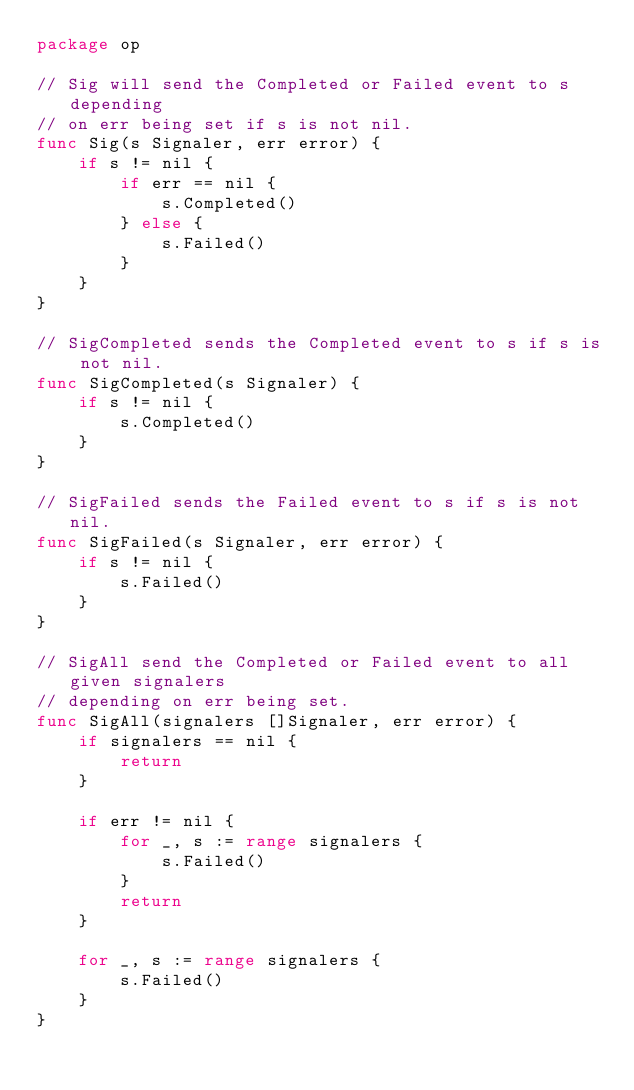Convert code to text. <code><loc_0><loc_0><loc_500><loc_500><_Go_>package op

// Sig will send the Completed or Failed event to s depending
// on err being set if s is not nil.
func Sig(s Signaler, err error) {
	if s != nil {
		if err == nil {
			s.Completed()
		} else {
			s.Failed()
		}
	}
}

// SigCompleted sends the Completed event to s if s is not nil.
func SigCompleted(s Signaler) {
	if s != nil {
		s.Completed()
	}
}

// SigFailed sends the Failed event to s if s is not nil.
func SigFailed(s Signaler, err error) {
	if s != nil {
		s.Failed()
	}
}

// SigAll send the Completed or Failed event to all given signalers
// depending on err being set.
func SigAll(signalers []Signaler, err error) {
	if signalers == nil {
		return
	}

	if err != nil {
		for _, s := range signalers {
			s.Failed()
		}
		return
	}

	for _, s := range signalers {
		s.Failed()
	}
}
</code> 